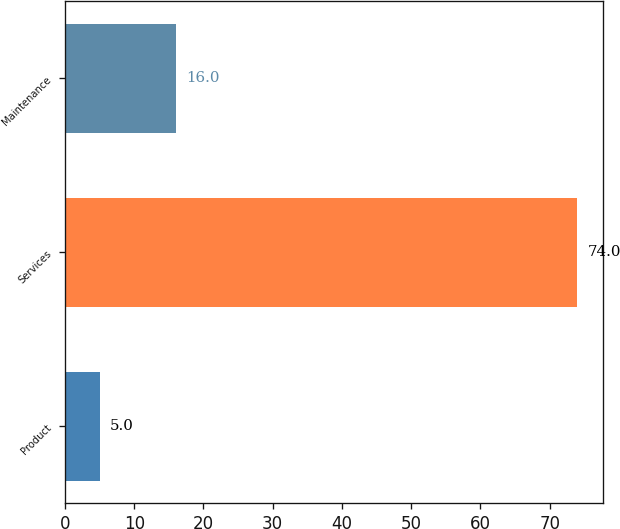Convert chart. <chart><loc_0><loc_0><loc_500><loc_500><bar_chart><fcel>Product<fcel>Services<fcel>Maintenance<nl><fcel>5<fcel>74<fcel>16<nl></chart> 